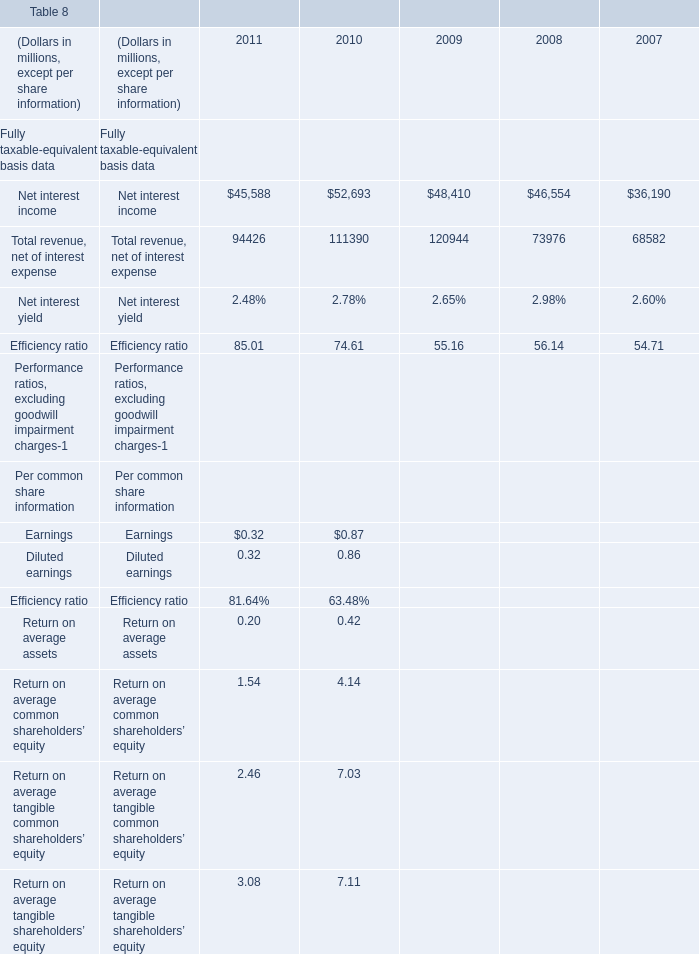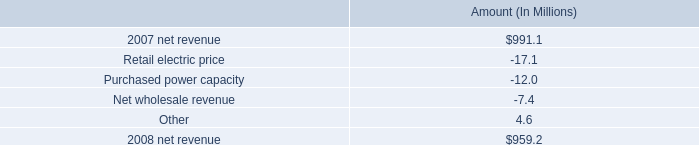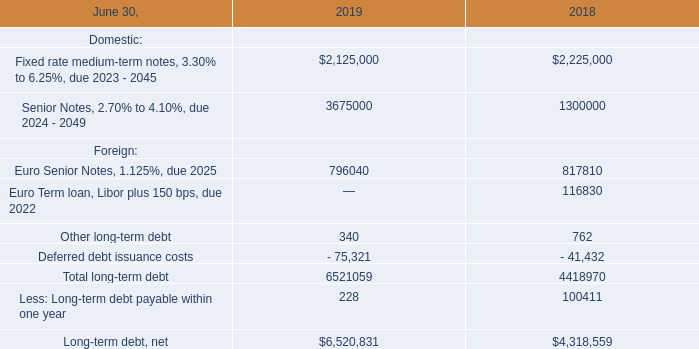what percent of the change in net revenue between 2007 and 2008 was due to purchased power capacity? 
Computations: (-12.0 / (959.2 - 991.1))
Answer: 0.37618. 